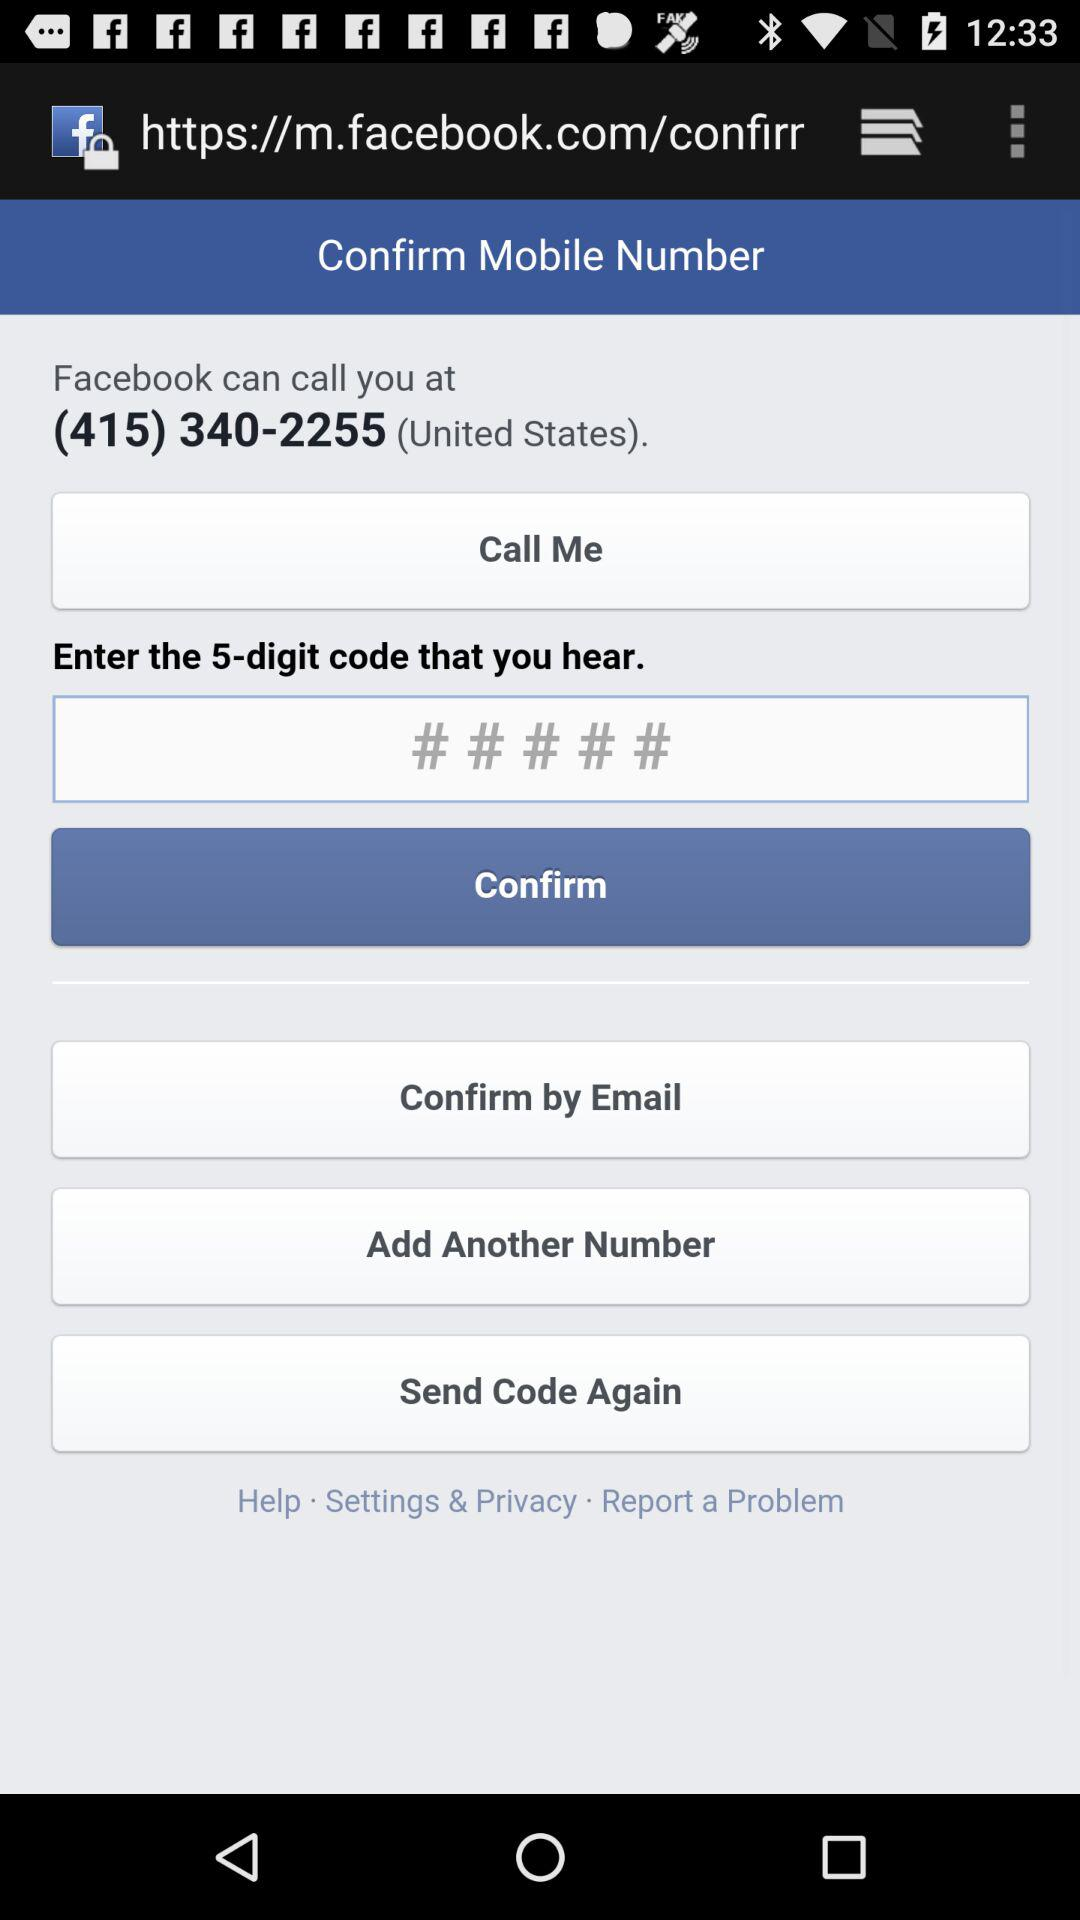How many digits are there in the code?
Answer the question using a single word or phrase. There are 5 digits, 